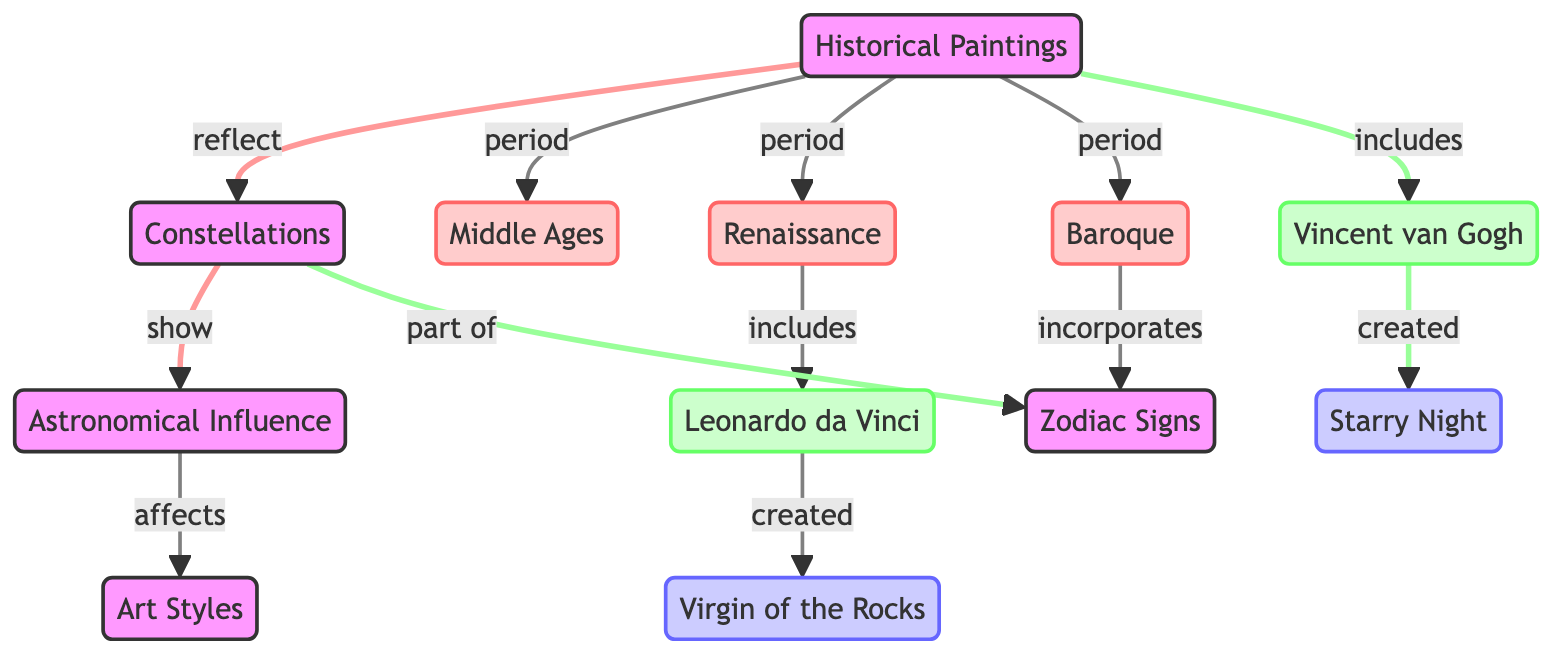What are the main periods of historical paintings depicted? The diagram directly connects the node "paintings" to "middle ages," "renaissance," and "baroque," indicating these are the main periods represented.
Answer: Middle Ages, Renaissance, Baroque Which artist is associated with the Renaissance period? The diagram shows a direct link from "renaissance" to "da vinci," indicating that Leonardo da Vinci is the artist from this period.
Answer: Leonardo da Vinci What artwork is created by Vincent van Gogh? The diagram links "van_gogh" to "gogh_starry_night," showing that "Starry Night" is the artwork created by him.
Answer: Starry Night How do constellations influence historical paintings according to the diagram? The diagram states that "paintings" reflect "constellations," which then show "influence." Thus, constellations affect the depiction found in historical paintings.
Answer: Influence Which art style is affected by astronomical influences? The diagram connects "influence" to "art_styles," indicating that art styles are impacted by the astronomical influences portrayed.
Answer: Art Styles What is part of the Baroque period's artistic expression? The connection from "baroque" to "zodiac" suggests that the incorporation of Zodiac signs is a characteristic of Baroque art.
Answer: Zodiac How many distinct artists are mentioned in the diagram? The diagram features two artists, da Vinci and van Gogh, one from the Renaissance and one from the Baroque period.
Answer: 2 Which work of art corresponds to Leonardo da Vinci? The connection shows that da Vinci created "Virgin of the Rocks," directly indicating the artwork linked to this artist.
Answer: Virgin of the Rocks What relationship exists between constellations and Zodiac signs? The diagram illustrates that constellations are part of the Zodiac signs, indicating a direct relationship.
Answer: Part of 